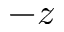<formula> <loc_0><loc_0><loc_500><loc_500>- z</formula> 